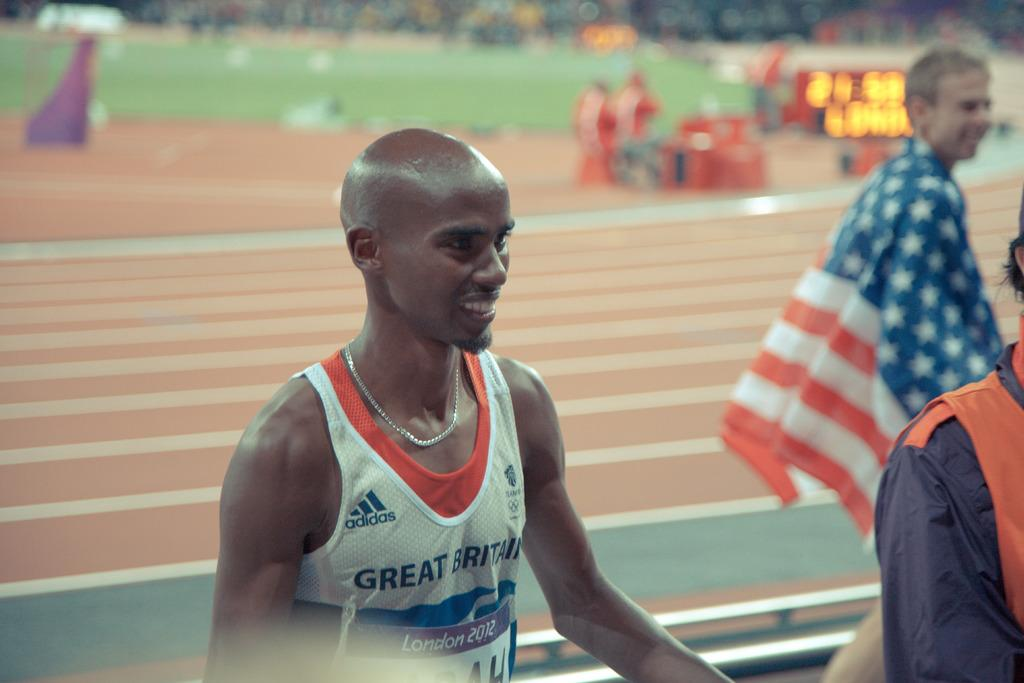<image>
Summarize the visual content of the image. A young athlete wears an Adidas uniform that says Great Britain over his chest. 